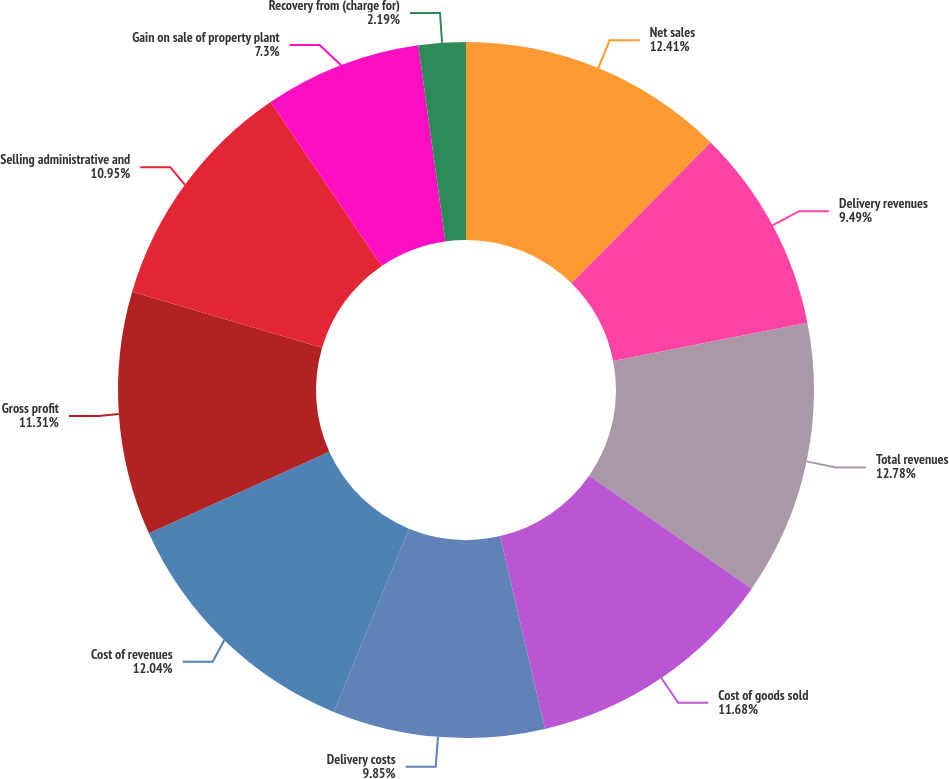Convert chart to OTSL. <chart><loc_0><loc_0><loc_500><loc_500><pie_chart><fcel>Net sales<fcel>Delivery revenues<fcel>Total revenues<fcel>Cost of goods sold<fcel>Delivery costs<fcel>Cost of revenues<fcel>Gross profit<fcel>Selling administrative and<fcel>Gain on sale of property plant<fcel>Recovery from (charge for)<nl><fcel>12.41%<fcel>9.49%<fcel>12.77%<fcel>11.68%<fcel>9.85%<fcel>12.04%<fcel>11.31%<fcel>10.95%<fcel>7.3%<fcel>2.19%<nl></chart> 